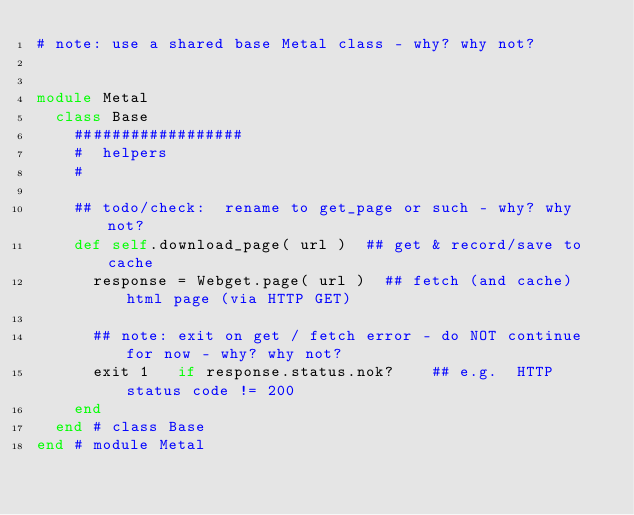Convert code to text. <code><loc_0><loc_0><loc_500><loc_500><_Ruby_># note: use a shared base Metal class - why? why not?


module Metal
  class Base
    ##################
    #  helpers
    #

    ## todo/check:  rename to get_page or such - why? why not?
    def self.download_page( url )  ## get & record/save to cache
      response = Webget.page( url )  ## fetch (and cache) html page (via HTTP GET)

      ## note: exit on get / fetch error - do NOT continue for now - why? why not?
      exit 1   if response.status.nok?    ## e.g.  HTTP status code != 200
    end
  end # class Base
end # module Metal
</code> 